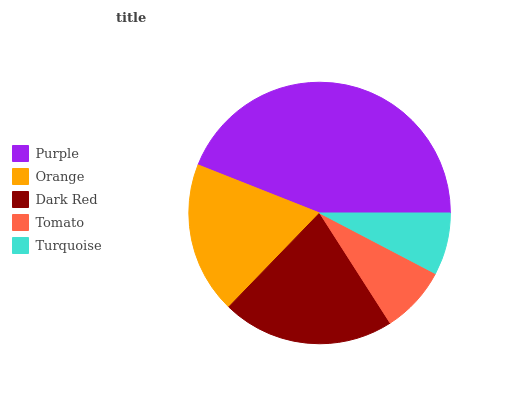Is Turquoise the minimum?
Answer yes or no. Yes. Is Purple the maximum?
Answer yes or no. Yes. Is Orange the minimum?
Answer yes or no. No. Is Orange the maximum?
Answer yes or no. No. Is Purple greater than Orange?
Answer yes or no. Yes. Is Orange less than Purple?
Answer yes or no. Yes. Is Orange greater than Purple?
Answer yes or no. No. Is Purple less than Orange?
Answer yes or no. No. Is Orange the high median?
Answer yes or no. Yes. Is Orange the low median?
Answer yes or no. Yes. Is Tomato the high median?
Answer yes or no. No. Is Tomato the low median?
Answer yes or no. No. 